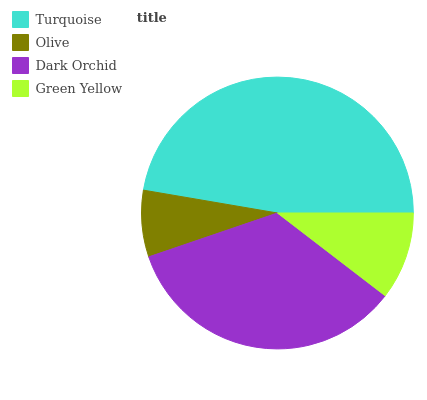Is Olive the minimum?
Answer yes or no. Yes. Is Turquoise the maximum?
Answer yes or no. Yes. Is Dark Orchid the minimum?
Answer yes or no. No. Is Dark Orchid the maximum?
Answer yes or no. No. Is Dark Orchid greater than Olive?
Answer yes or no. Yes. Is Olive less than Dark Orchid?
Answer yes or no. Yes. Is Olive greater than Dark Orchid?
Answer yes or no. No. Is Dark Orchid less than Olive?
Answer yes or no. No. Is Dark Orchid the high median?
Answer yes or no. Yes. Is Green Yellow the low median?
Answer yes or no. Yes. Is Olive the high median?
Answer yes or no. No. Is Olive the low median?
Answer yes or no. No. 